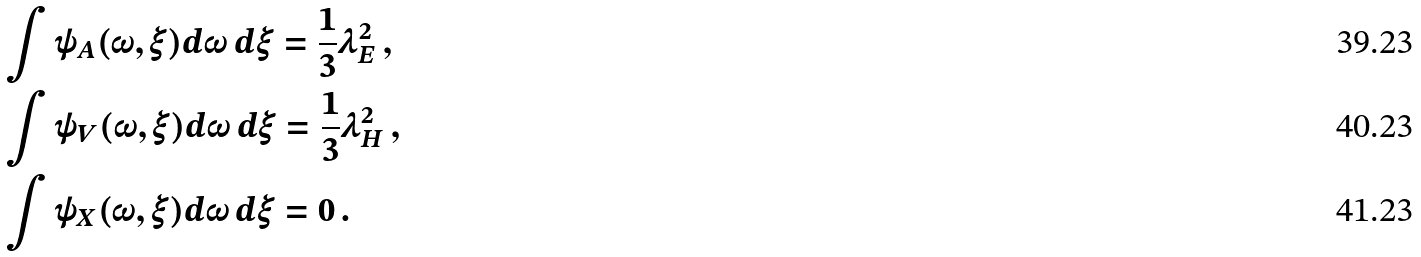<formula> <loc_0><loc_0><loc_500><loc_500>& \int \psi _ { A } ( \omega , \xi ) d \omega \, d \xi = \frac { 1 } { 3 } \lambda _ { E } ^ { 2 } \, , \\ & \int \psi _ { V } ( \omega , \xi ) d \omega \, d \xi = \frac { 1 } { 3 } \lambda _ { H } ^ { 2 } \, , \\ & \int \psi _ { X } ( \omega , \xi ) d \omega \, d \xi = 0 \, .</formula> 